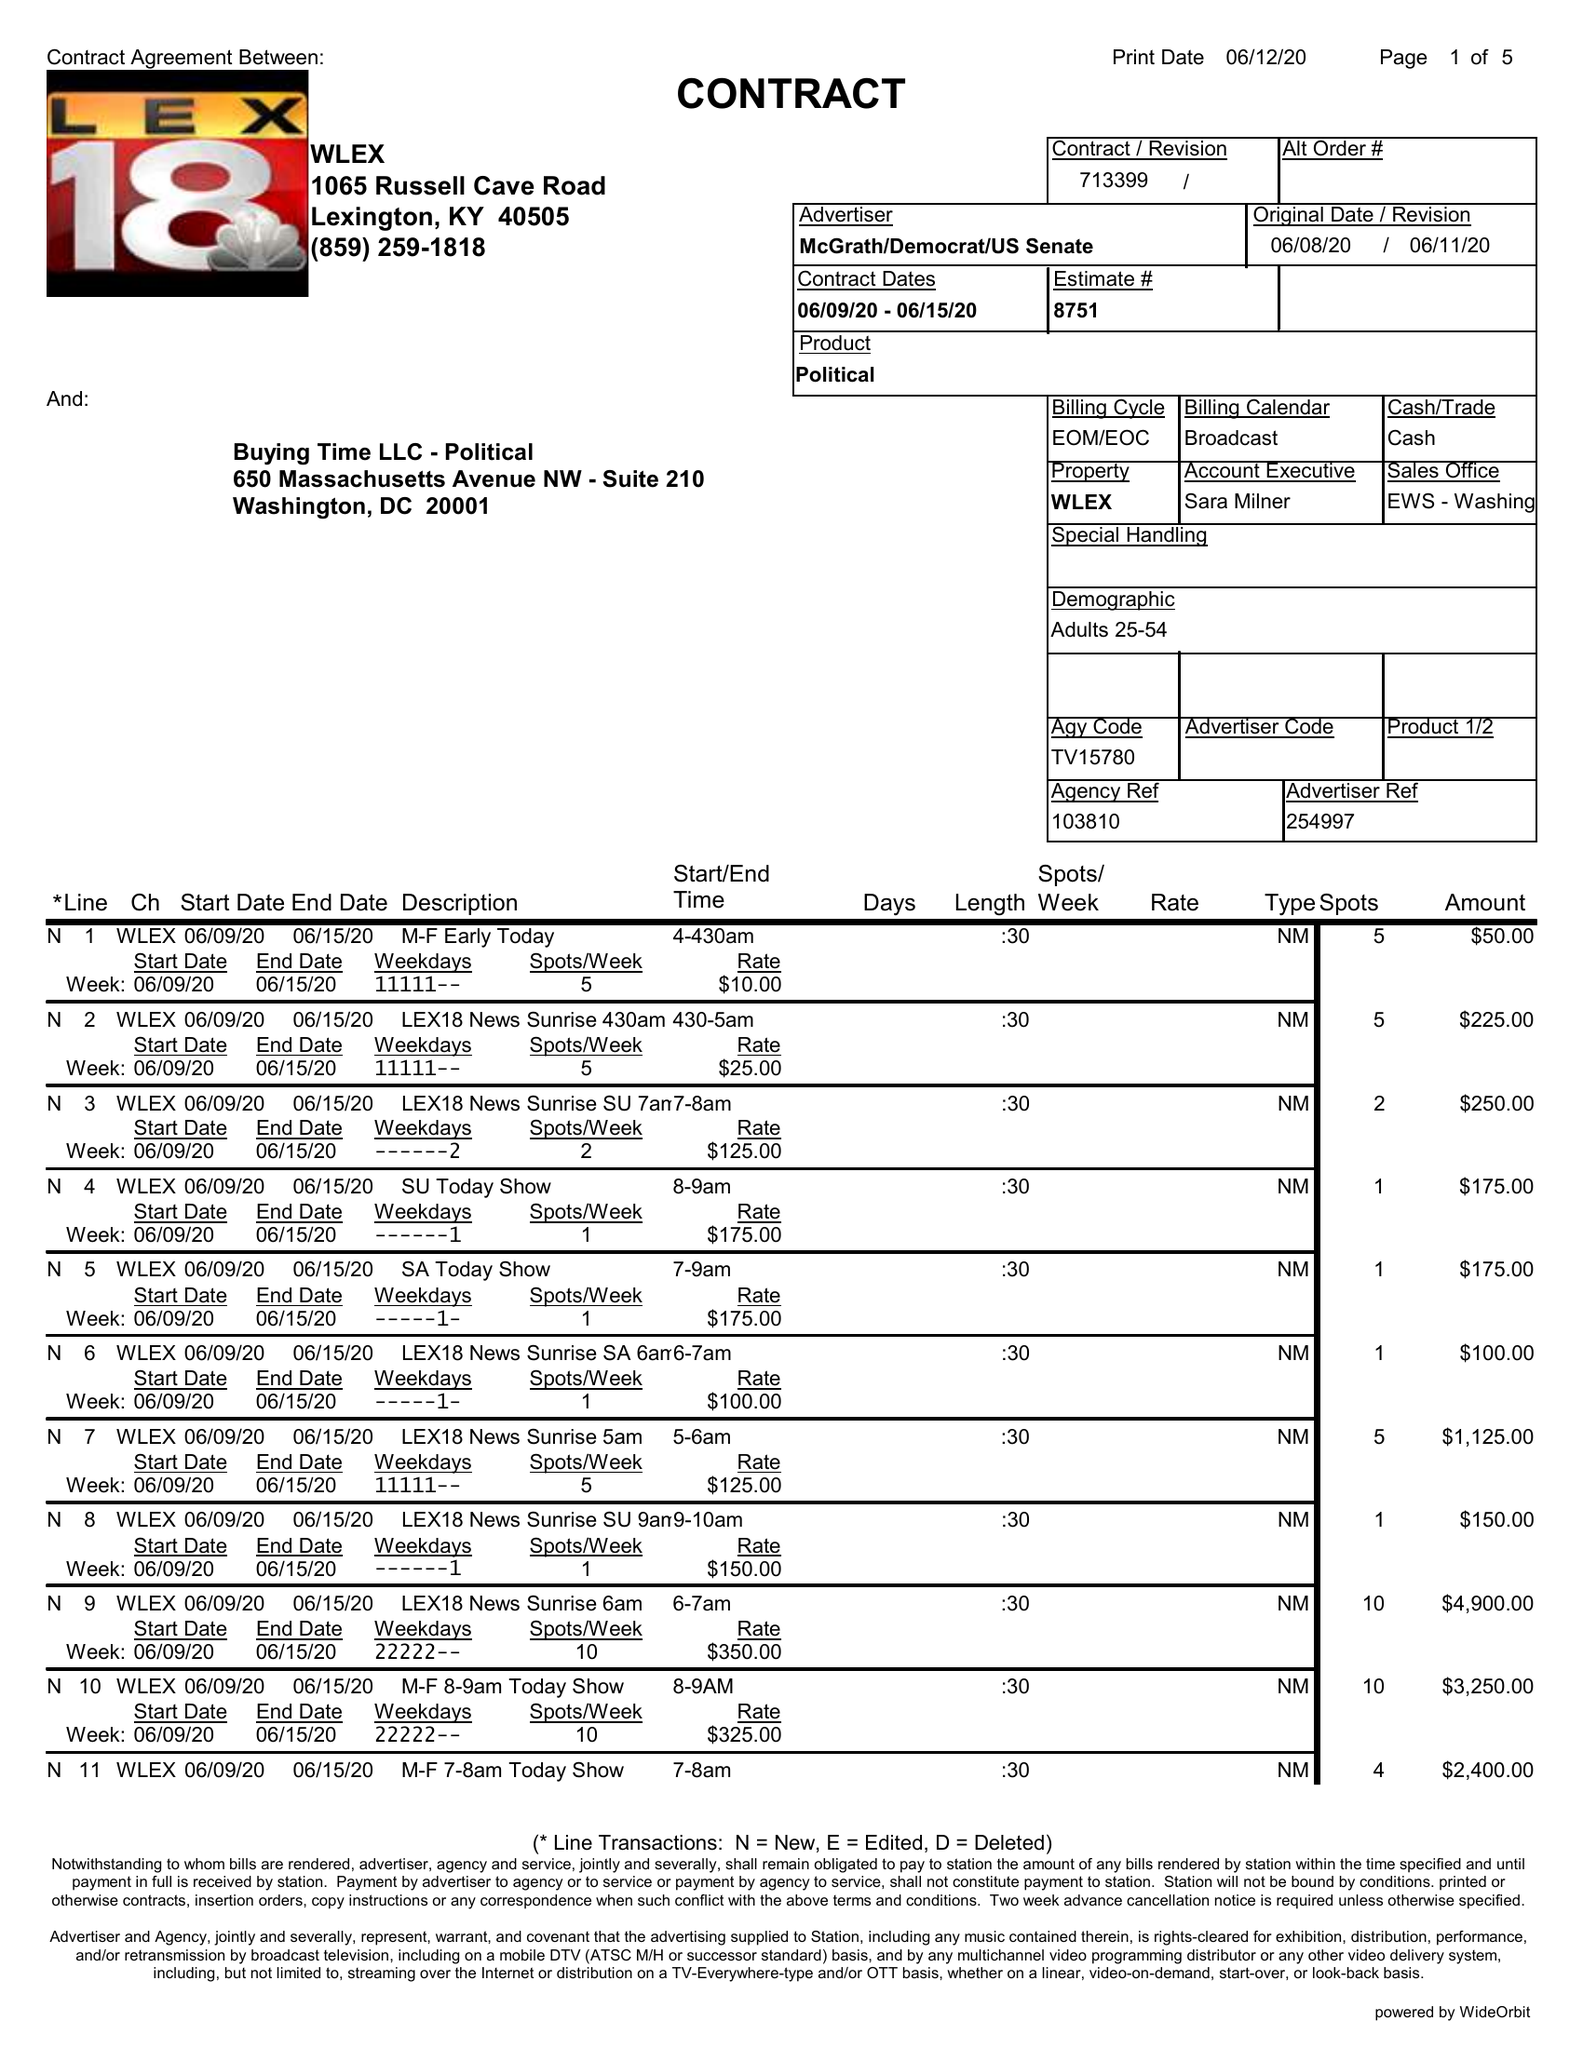What is the value for the contract_num?
Answer the question using a single word or phrase. 713399 